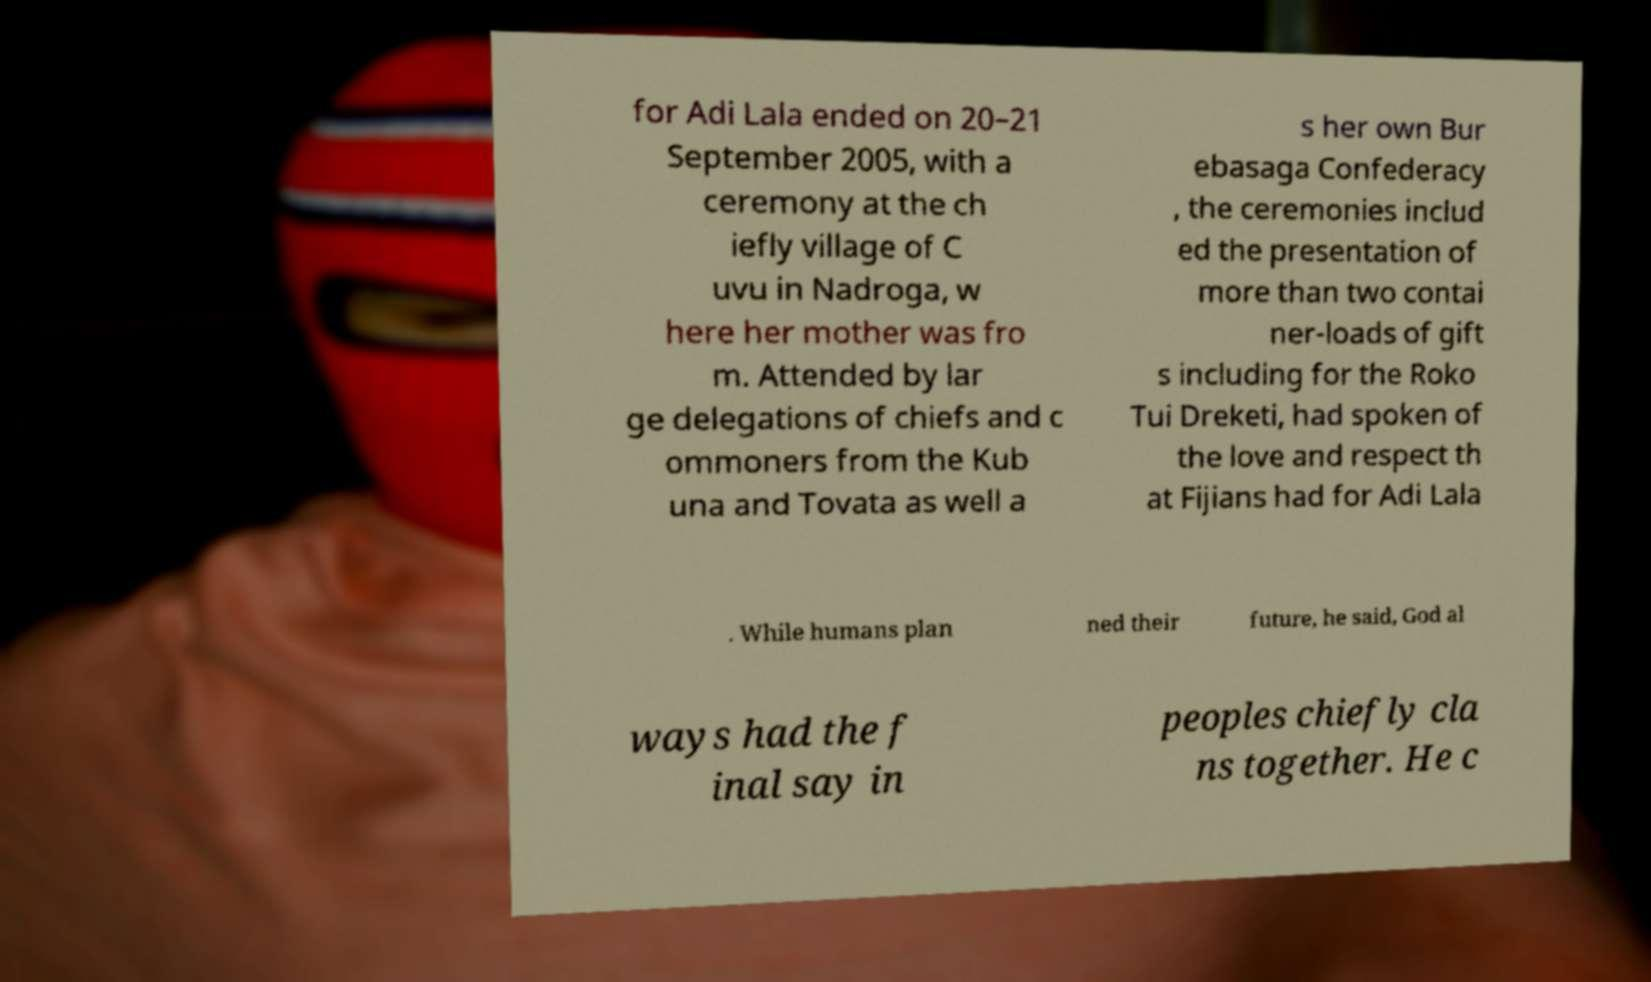Could you extract and type out the text from this image? for Adi Lala ended on 20–21 September 2005, with a ceremony at the ch iefly village of C uvu in Nadroga, w here her mother was fro m. Attended by lar ge delegations of chiefs and c ommoners from the Kub una and Tovata as well a s her own Bur ebasaga Confederacy , the ceremonies includ ed the presentation of more than two contai ner-loads of gift s including for the Roko Tui Dreketi, had spoken of the love and respect th at Fijians had for Adi Lala . While humans plan ned their future, he said, God al ways had the f inal say in peoples chiefly cla ns together. He c 